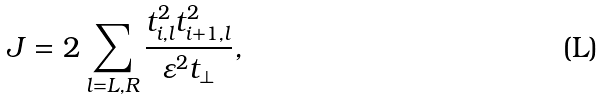<formula> <loc_0><loc_0><loc_500><loc_500>J = 2 \sum _ { l = L , R } \frac { t _ { i , l } ^ { 2 } t _ { i + 1 , l } ^ { 2 } } { \varepsilon ^ { 2 } t _ { \perp } } ,</formula> 